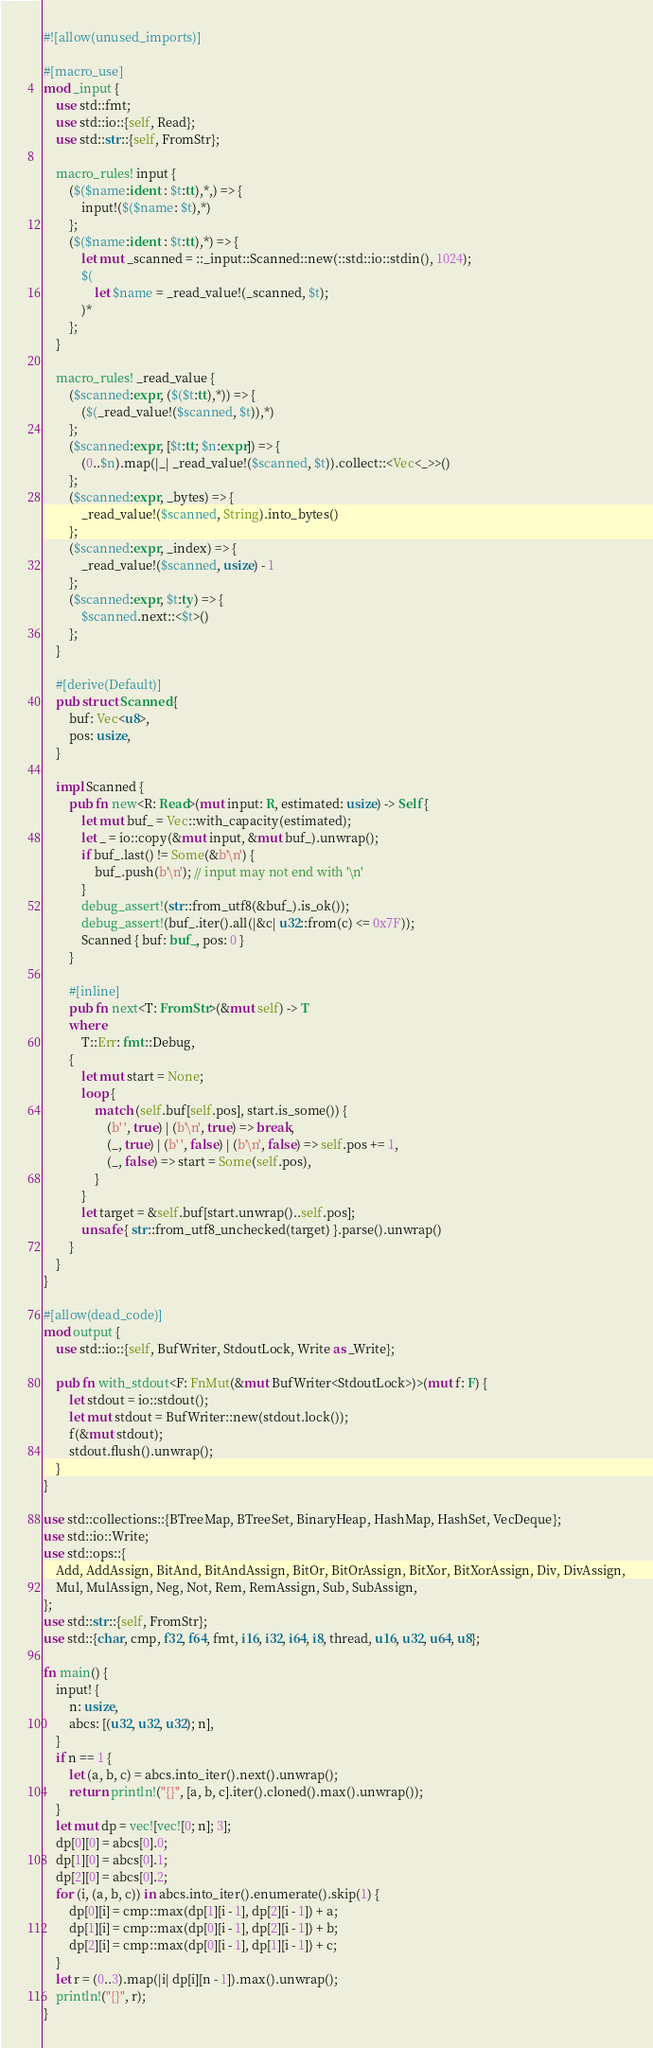Convert code to text. <code><loc_0><loc_0><loc_500><loc_500><_Rust_>#![allow(unused_imports)]

#[macro_use]
mod _input {
    use std::fmt;
    use std::io::{self, Read};
    use std::str::{self, FromStr};

    macro_rules! input {
        ($($name:ident : $t:tt),*,) => {
            input!($($name: $t),*)
        };
        ($($name:ident : $t:tt),*) => {
            let mut _scanned = ::_input::Scanned::new(::std::io::stdin(), 1024);
            $(
                let $name = _read_value!(_scanned, $t);
            )*
        };
    }

    macro_rules! _read_value {
        ($scanned:expr, ($($t:tt),*)) => {
            ($(_read_value!($scanned, $t)),*)
        };
        ($scanned:expr, [$t:tt; $n:expr]) => {
            (0..$n).map(|_| _read_value!($scanned, $t)).collect::<Vec<_>>()
        };
        ($scanned:expr, _bytes) => {
            _read_value!($scanned, String).into_bytes()
        };
        ($scanned:expr, _index) => {
            _read_value!($scanned, usize) - 1
        };
        ($scanned:expr, $t:ty) => {
            $scanned.next::<$t>()
        };
    }

    #[derive(Default)]
    pub struct Scanned {
        buf: Vec<u8>,
        pos: usize,
    }

    impl Scanned {
        pub fn new<R: Read>(mut input: R, estimated: usize) -> Self {
            let mut buf_ = Vec::with_capacity(estimated);
            let _ = io::copy(&mut input, &mut buf_).unwrap();
            if buf_.last() != Some(&b'\n') {
                buf_.push(b'\n'); // input may not end with '\n'
            }
            debug_assert!(str::from_utf8(&buf_).is_ok());
            debug_assert!(buf_.iter().all(|&c| u32::from(c) <= 0x7F));
            Scanned { buf: buf_, pos: 0 }
        }

        #[inline]
        pub fn next<T: FromStr>(&mut self) -> T
        where
            T::Err: fmt::Debug,
        {
            let mut start = None;
            loop {
                match (self.buf[self.pos], start.is_some()) {
                    (b' ', true) | (b'\n', true) => break,
                    (_, true) | (b' ', false) | (b'\n', false) => self.pos += 1,
                    (_, false) => start = Some(self.pos),
                }
            }
            let target = &self.buf[start.unwrap()..self.pos];
            unsafe { str::from_utf8_unchecked(target) }.parse().unwrap()
        }
    }
}

#[allow(dead_code)]
mod output {
    use std::io::{self, BufWriter, StdoutLock, Write as _Write};

    pub fn with_stdout<F: FnMut(&mut BufWriter<StdoutLock>)>(mut f: F) {
        let stdout = io::stdout();
        let mut stdout = BufWriter::new(stdout.lock());
        f(&mut stdout);
        stdout.flush().unwrap();
    }
}

use std::collections::{BTreeMap, BTreeSet, BinaryHeap, HashMap, HashSet, VecDeque};
use std::io::Write;
use std::ops::{
    Add, AddAssign, BitAnd, BitAndAssign, BitOr, BitOrAssign, BitXor, BitXorAssign, Div, DivAssign,
    Mul, MulAssign, Neg, Not, Rem, RemAssign, Sub, SubAssign,
};
use std::str::{self, FromStr};
use std::{char, cmp, f32, f64, fmt, i16, i32, i64, i8, thread, u16, u32, u64, u8};

fn main() {
    input! {
        n: usize,
        abcs: [(u32, u32, u32); n],
    }
    if n == 1 {
        let (a, b, c) = abcs.into_iter().next().unwrap();
        return println!("{}", [a, b, c].iter().cloned().max().unwrap());
    }
    let mut dp = vec![vec![0; n]; 3];
    dp[0][0] = abcs[0].0;
    dp[1][0] = abcs[0].1;
    dp[2][0] = abcs[0].2;
    for (i, (a, b, c)) in abcs.into_iter().enumerate().skip(1) {
        dp[0][i] = cmp::max(dp[1][i - 1], dp[2][i - 1]) + a;
        dp[1][i] = cmp::max(dp[0][i - 1], dp[2][i - 1]) + b;
        dp[2][i] = cmp::max(dp[0][i - 1], dp[1][i - 1]) + c;
    }
    let r = (0..3).map(|i| dp[i][n - 1]).max().unwrap();
    println!("{}", r);
}
</code> 